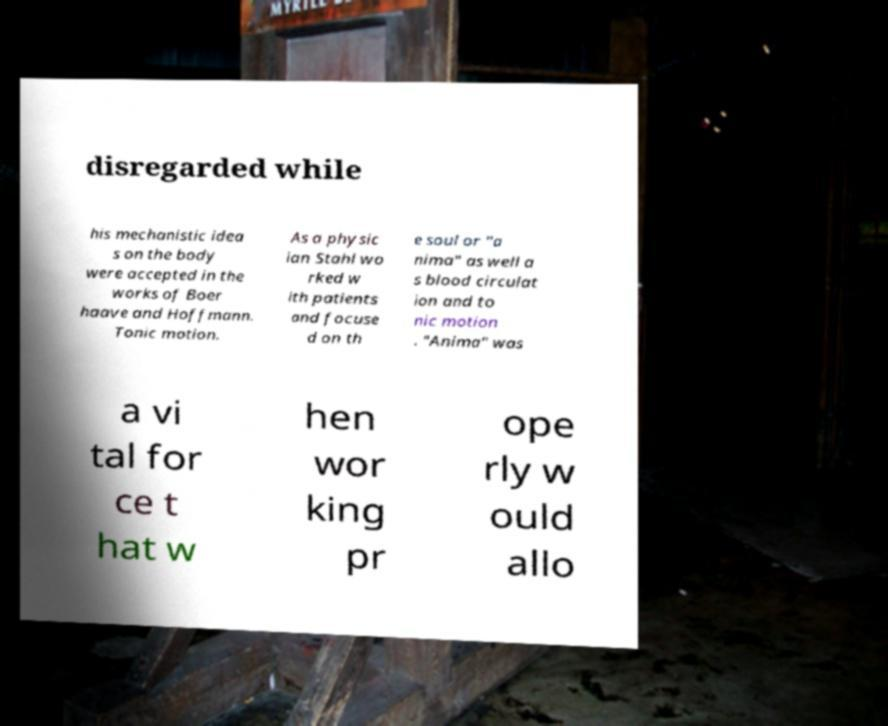Can you accurately transcribe the text from the provided image for me? disregarded while his mechanistic idea s on the body were accepted in the works of Boer haave and Hoffmann. Tonic motion. As a physic ian Stahl wo rked w ith patients and focuse d on th e soul or "a nima" as well a s blood circulat ion and to nic motion . "Anima" was a vi tal for ce t hat w hen wor king pr ope rly w ould allo 